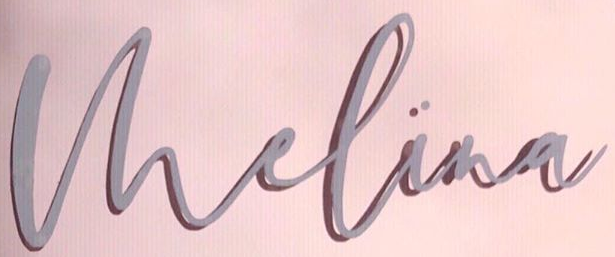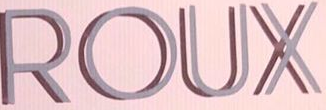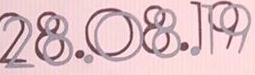What text is displayed in these images sequentially, separated by a semicolon? Vhelina; ROUX; 28.08.19 